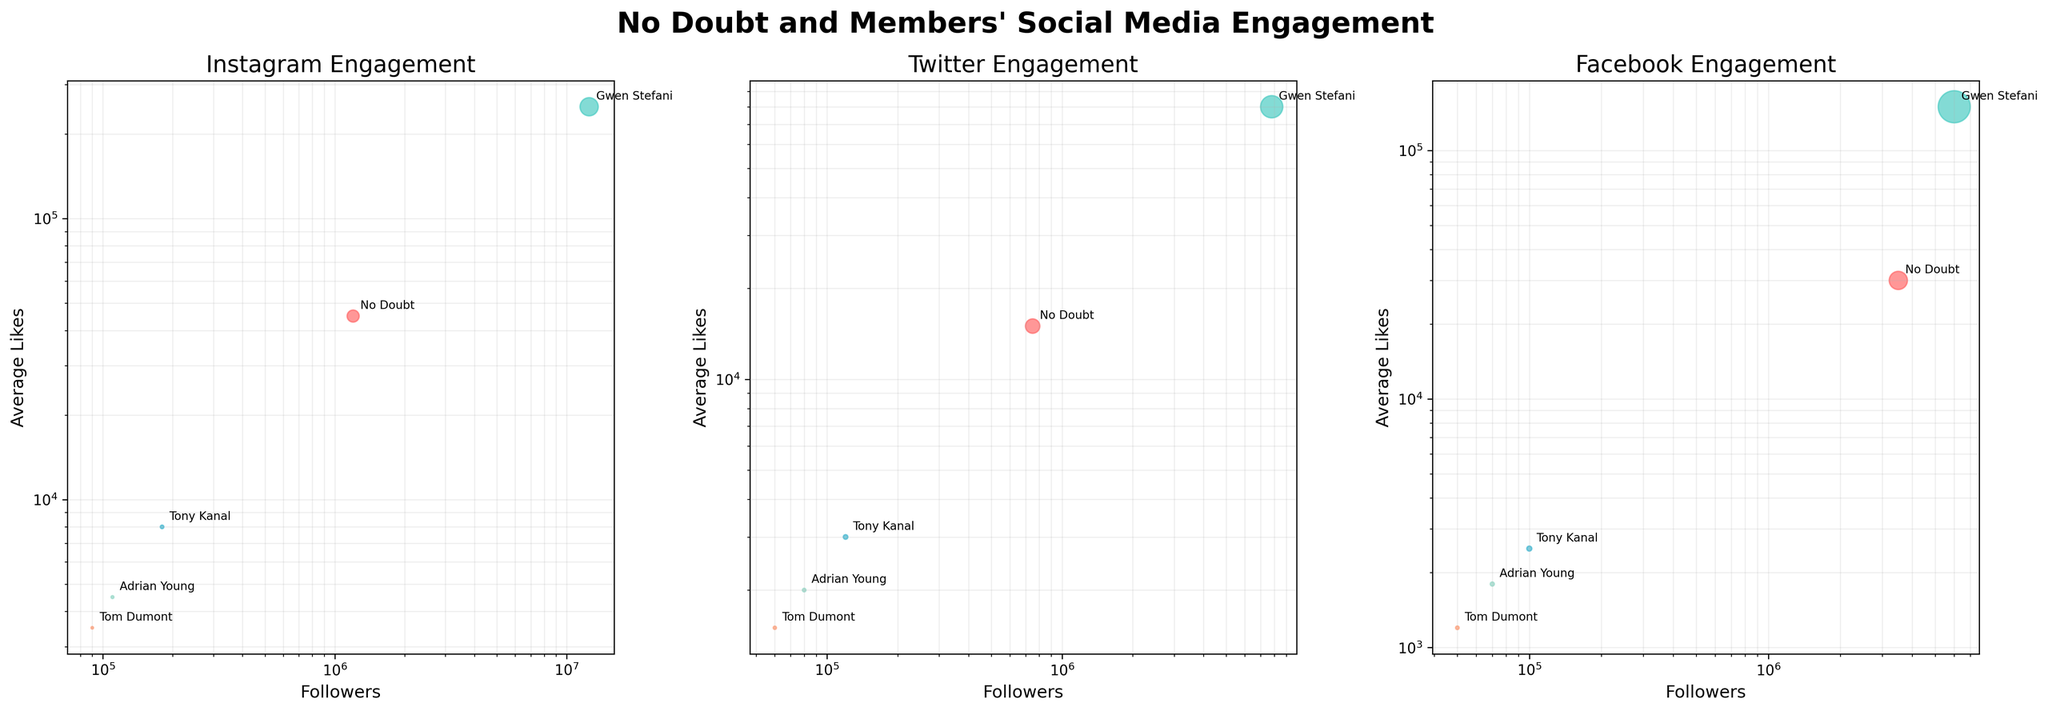Which account has the most followers on Instagram? By looking at the Instagram subplot, Gwen Stefani's bubble is positioned the furthest to the right on the x-axis, which represents followers. This indicates she has the most followers on Instagram.
Answer: Gwen Stefani Which platform shows the highest average likes for No Doubt? Compare the average likes of No Doubt across all subplots (Instagram, Twitter, Facebook). No Doubt's bubble is highest on the y-axis in the Instagram subplot, indicating the highest average likes on Instagram.
Answer: Instagram Which member has the smallest average shares on Twitter? Look at the Twitter subplot and compare the bubble sizes for all members. Tom Dumont's bubble is the smallest, indicating he has the smallest average shares on Twitter.
Answer: Tom Dumont On which platform does Adrian Young have more followers compared to Tony Kanal? Compare the bubbles for Adrian Young and Tony Kanal across Instagram, Twitter, and Facebook subplots. On Instagram, Adrian Young's bubble is to the right of Tony Kanal’s, indicating more followers.
Answer: Instagram How do the average likes for Gwen Stefani on Instagram compare to her average likes on Facebook? Compare the y-axis positions (average likes) of Gwen Stefani's bubbles in the Instagram and Facebook subplots. Her bubble is higher on the Instagram subplot, indicating more average likes there.
Answer: More on Instagram Which platform shows the least average likes for Tony Kanal? Compare Tony Kanal's bubbles across all three subplots. The Twitter subplot has Tony Kanal's bubble positioned lowest on the y-axis, showing the least average likes.
Answer: Twitter How do the average comments on Facebook for No Doubt compare to the average comments for Tony Kanal on Instagram? Although the figure doesn't explicitly show average comments, you can infer from average likes and general engagement. No Doubt's average comments on Facebook (4000) are substantially higher than Tony Kanal's average comments on Instagram (500).
Answer: Higher for No Doubt on Facebook What is the visual difference between the average shares for Tom Dumont on Twitter versus Instagram? Compare the bubble sizes for Tom Dumont in the Twitter and Instagram subplots. The bubble for Tom Dumont is smaller in the Twitter subplot compared to the Instagram subplot, indicating fewer average shares on Twitter.
Answer: Smaller on Twitter On which platform does No Doubt have the highest average shares? Compare the bubble sizes for No Doubt across all three subplots. No Doubt's bubble is largest on Facebook, indicating the highest average shares on that platform.
Answer: Facebook 